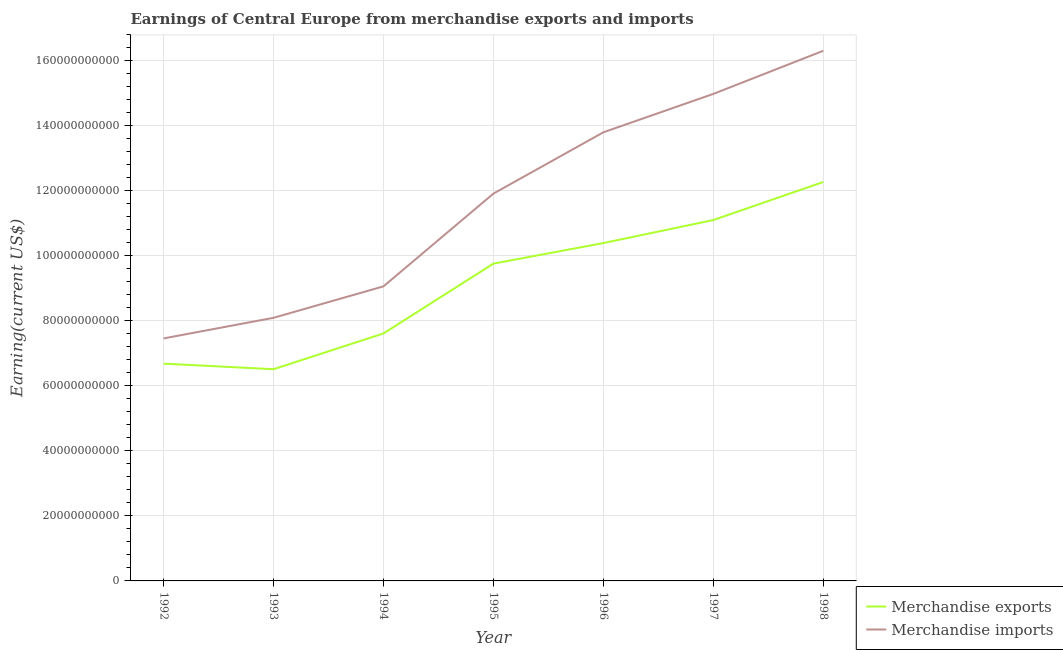How many different coloured lines are there?
Your answer should be very brief. 2. Does the line corresponding to earnings from merchandise exports intersect with the line corresponding to earnings from merchandise imports?
Make the answer very short. No. Is the number of lines equal to the number of legend labels?
Provide a succinct answer. Yes. What is the earnings from merchandise imports in 1992?
Your answer should be very brief. 7.46e+1. Across all years, what is the maximum earnings from merchandise exports?
Give a very brief answer. 1.23e+11. Across all years, what is the minimum earnings from merchandise exports?
Keep it short and to the point. 6.51e+1. In which year was the earnings from merchandise imports maximum?
Offer a terse response. 1998. What is the total earnings from merchandise imports in the graph?
Offer a very short reply. 8.16e+11. What is the difference between the earnings from merchandise imports in 1992 and that in 1997?
Ensure brevity in your answer.  -7.52e+1. What is the difference between the earnings from merchandise exports in 1996 and the earnings from merchandise imports in 1995?
Keep it short and to the point. -1.52e+1. What is the average earnings from merchandise exports per year?
Keep it short and to the point. 9.19e+1. In the year 1995, what is the difference between the earnings from merchandise imports and earnings from merchandise exports?
Your answer should be very brief. 2.15e+1. What is the ratio of the earnings from merchandise imports in 1992 to that in 1998?
Give a very brief answer. 0.46. Is the earnings from merchandise exports in 1994 less than that in 1996?
Offer a terse response. Yes. What is the difference between the highest and the second highest earnings from merchandise exports?
Your answer should be compact. 1.17e+1. What is the difference between the highest and the lowest earnings from merchandise imports?
Ensure brevity in your answer.  8.85e+1. Is the earnings from merchandise imports strictly greater than the earnings from merchandise exports over the years?
Offer a very short reply. Yes. Is the earnings from merchandise exports strictly less than the earnings from merchandise imports over the years?
Provide a short and direct response. Yes. How many years are there in the graph?
Keep it short and to the point. 7. Does the graph contain grids?
Keep it short and to the point. Yes. How many legend labels are there?
Offer a terse response. 2. What is the title of the graph?
Keep it short and to the point. Earnings of Central Europe from merchandise exports and imports. Does "Nonresident" appear as one of the legend labels in the graph?
Offer a terse response. No. What is the label or title of the Y-axis?
Make the answer very short. Earning(current US$). What is the Earning(current US$) in Merchandise exports in 1992?
Offer a very short reply. 6.69e+1. What is the Earning(current US$) in Merchandise imports in 1992?
Provide a succinct answer. 7.46e+1. What is the Earning(current US$) of Merchandise exports in 1993?
Make the answer very short. 6.51e+1. What is the Earning(current US$) of Merchandise imports in 1993?
Your answer should be compact. 8.10e+1. What is the Earning(current US$) in Merchandise exports in 1994?
Provide a short and direct response. 7.61e+1. What is the Earning(current US$) in Merchandise imports in 1994?
Offer a terse response. 9.06e+1. What is the Earning(current US$) in Merchandise exports in 1995?
Give a very brief answer. 9.76e+1. What is the Earning(current US$) in Merchandise imports in 1995?
Ensure brevity in your answer.  1.19e+11. What is the Earning(current US$) of Merchandise exports in 1996?
Offer a very short reply. 1.04e+11. What is the Earning(current US$) of Merchandise imports in 1996?
Your response must be concise. 1.38e+11. What is the Earning(current US$) of Merchandise exports in 1997?
Your answer should be compact. 1.11e+11. What is the Earning(current US$) in Merchandise imports in 1997?
Keep it short and to the point. 1.50e+11. What is the Earning(current US$) in Merchandise exports in 1998?
Give a very brief answer. 1.23e+11. What is the Earning(current US$) in Merchandise imports in 1998?
Ensure brevity in your answer.  1.63e+11. Across all years, what is the maximum Earning(current US$) in Merchandise exports?
Provide a succinct answer. 1.23e+11. Across all years, what is the maximum Earning(current US$) of Merchandise imports?
Your response must be concise. 1.63e+11. Across all years, what is the minimum Earning(current US$) of Merchandise exports?
Keep it short and to the point. 6.51e+1. Across all years, what is the minimum Earning(current US$) of Merchandise imports?
Make the answer very short. 7.46e+1. What is the total Earning(current US$) of Merchandise exports in the graph?
Your answer should be compact. 6.43e+11. What is the total Earning(current US$) in Merchandise imports in the graph?
Give a very brief answer. 8.16e+11. What is the difference between the Earning(current US$) in Merchandise exports in 1992 and that in 1993?
Your response must be concise. 1.72e+09. What is the difference between the Earning(current US$) in Merchandise imports in 1992 and that in 1993?
Provide a succinct answer. -6.34e+09. What is the difference between the Earning(current US$) in Merchandise exports in 1992 and that in 1994?
Offer a terse response. -9.28e+09. What is the difference between the Earning(current US$) of Merchandise imports in 1992 and that in 1994?
Offer a terse response. -1.60e+1. What is the difference between the Earning(current US$) in Merchandise exports in 1992 and that in 1995?
Ensure brevity in your answer.  -3.08e+1. What is the difference between the Earning(current US$) of Merchandise imports in 1992 and that in 1995?
Your answer should be compact. -4.46e+1. What is the difference between the Earning(current US$) of Merchandise exports in 1992 and that in 1996?
Ensure brevity in your answer.  -3.71e+1. What is the difference between the Earning(current US$) in Merchandise imports in 1992 and that in 1996?
Provide a succinct answer. -6.34e+1. What is the difference between the Earning(current US$) in Merchandise exports in 1992 and that in 1997?
Give a very brief answer. -4.42e+1. What is the difference between the Earning(current US$) in Merchandise imports in 1992 and that in 1997?
Offer a very short reply. -7.52e+1. What is the difference between the Earning(current US$) of Merchandise exports in 1992 and that in 1998?
Keep it short and to the point. -5.59e+1. What is the difference between the Earning(current US$) of Merchandise imports in 1992 and that in 1998?
Provide a succinct answer. -8.85e+1. What is the difference between the Earning(current US$) in Merchandise exports in 1993 and that in 1994?
Make the answer very short. -1.10e+1. What is the difference between the Earning(current US$) in Merchandise imports in 1993 and that in 1994?
Ensure brevity in your answer.  -9.67e+09. What is the difference between the Earning(current US$) in Merchandise exports in 1993 and that in 1995?
Keep it short and to the point. -3.25e+1. What is the difference between the Earning(current US$) of Merchandise imports in 1993 and that in 1995?
Ensure brevity in your answer.  -3.82e+1. What is the difference between the Earning(current US$) in Merchandise exports in 1993 and that in 1996?
Your response must be concise. -3.88e+1. What is the difference between the Earning(current US$) in Merchandise imports in 1993 and that in 1996?
Offer a terse response. -5.71e+1. What is the difference between the Earning(current US$) of Merchandise exports in 1993 and that in 1997?
Provide a succinct answer. -4.59e+1. What is the difference between the Earning(current US$) in Merchandise imports in 1993 and that in 1997?
Make the answer very short. -6.89e+1. What is the difference between the Earning(current US$) in Merchandise exports in 1993 and that in 1998?
Offer a terse response. -5.76e+1. What is the difference between the Earning(current US$) in Merchandise imports in 1993 and that in 1998?
Give a very brief answer. -8.22e+1. What is the difference between the Earning(current US$) of Merchandise exports in 1994 and that in 1995?
Your response must be concise. -2.15e+1. What is the difference between the Earning(current US$) in Merchandise imports in 1994 and that in 1995?
Provide a succinct answer. -2.85e+1. What is the difference between the Earning(current US$) in Merchandise exports in 1994 and that in 1996?
Offer a terse response. -2.78e+1. What is the difference between the Earning(current US$) of Merchandise imports in 1994 and that in 1996?
Your answer should be very brief. -4.74e+1. What is the difference between the Earning(current US$) in Merchandise exports in 1994 and that in 1997?
Make the answer very short. -3.49e+1. What is the difference between the Earning(current US$) in Merchandise imports in 1994 and that in 1997?
Provide a short and direct response. -5.92e+1. What is the difference between the Earning(current US$) of Merchandise exports in 1994 and that in 1998?
Offer a terse response. -4.66e+1. What is the difference between the Earning(current US$) in Merchandise imports in 1994 and that in 1998?
Ensure brevity in your answer.  -7.25e+1. What is the difference between the Earning(current US$) of Merchandise exports in 1995 and that in 1996?
Make the answer very short. -6.33e+09. What is the difference between the Earning(current US$) of Merchandise imports in 1995 and that in 1996?
Offer a very short reply. -1.89e+1. What is the difference between the Earning(current US$) of Merchandise exports in 1995 and that in 1997?
Provide a short and direct response. -1.34e+1. What is the difference between the Earning(current US$) of Merchandise imports in 1995 and that in 1997?
Ensure brevity in your answer.  -3.07e+1. What is the difference between the Earning(current US$) in Merchandise exports in 1995 and that in 1998?
Offer a very short reply. -2.51e+1. What is the difference between the Earning(current US$) of Merchandise imports in 1995 and that in 1998?
Provide a short and direct response. -4.39e+1. What is the difference between the Earning(current US$) of Merchandise exports in 1996 and that in 1997?
Your answer should be compact. -7.09e+09. What is the difference between the Earning(current US$) of Merchandise imports in 1996 and that in 1997?
Your response must be concise. -1.18e+1. What is the difference between the Earning(current US$) of Merchandise exports in 1996 and that in 1998?
Offer a terse response. -1.88e+1. What is the difference between the Earning(current US$) in Merchandise imports in 1996 and that in 1998?
Your answer should be very brief. -2.51e+1. What is the difference between the Earning(current US$) of Merchandise exports in 1997 and that in 1998?
Provide a short and direct response. -1.17e+1. What is the difference between the Earning(current US$) in Merchandise imports in 1997 and that in 1998?
Provide a short and direct response. -1.33e+1. What is the difference between the Earning(current US$) in Merchandise exports in 1992 and the Earning(current US$) in Merchandise imports in 1993?
Give a very brief answer. -1.41e+1. What is the difference between the Earning(current US$) of Merchandise exports in 1992 and the Earning(current US$) of Merchandise imports in 1994?
Your answer should be compact. -2.38e+1. What is the difference between the Earning(current US$) in Merchandise exports in 1992 and the Earning(current US$) in Merchandise imports in 1995?
Your answer should be compact. -5.23e+1. What is the difference between the Earning(current US$) in Merchandise exports in 1992 and the Earning(current US$) in Merchandise imports in 1996?
Give a very brief answer. -7.12e+1. What is the difference between the Earning(current US$) of Merchandise exports in 1992 and the Earning(current US$) of Merchandise imports in 1997?
Keep it short and to the point. -8.30e+1. What is the difference between the Earning(current US$) in Merchandise exports in 1992 and the Earning(current US$) in Merchandise imports in 1998?
Ensure brevity in your answer.  -9.63e+1. What is the difference between the Earning(current US$) of Merchandise exports in 1993 and the Earning(current US$) of Merchandise imports in 1994?
Keep it short and to the point. -2.55e+1. What is the difference between the Earning(current US$) in Merchandise exports in 1993 and the Earning(current US$) in Merchandise imports in 1995?
Your answer should be very brief. -5.40e+1. What is the difference between the Earning(current US$) of Merchandise exports in 1993 and the Earning(current US$) of Merchandise imports in 1996?
Give a very brief answer. -7.29e+1. What is the difference between the Earning(current US$) in Merchandise exports in 1993 and the Earning(current US$) in Merchandise imports in 1997?
Your response must be concise. -8.47e+1. What is the difference between the Earning(current US$) of Merchandise exports in 1993 and the Earning(current US$) of Merchandise imports in 1998?
Your response must be concise. -9.80e+1. What is the difference between the Earning(current US$) of Merchandise exports in 1994 and the Earning(current US$) of Merchandise imports in 1995?
Ensure brevity in your answer.  -4.30e+1. What is the difference between the Earning(current US$) in Merchandise exports in 1994 and the Earning(current US$) in Merchandise imports in 1996?
Ensure brevity in your answer.  -6.19e+1. What is the difference between the Earning(current US$) in Merchandise exports in 1994 and the Earning(current US$) in Merchandise imports in 1997?
Provide a succinct answer. -7.37e+1. What is the difference between the Earning(current US$) of Merchandise exports in 1994 and the Earning(current US$) of Merchandise imports in 1998?
Your answer should be compact. -8.70e+1. What is the difference between the Earning(current US$) in Merchandise exports in 1995 and the Earning(current US$) in Merchandise imports in 1996?
Your answer should be very brief. -4.04e+1. What is the difference between the Earning(current US$) of Merchandise exports in 1995 and the Earning(current US$) of Merchandise imports in 1997?
Your answer should be very brief. -5.22e+1. What is the difference between the Earning(current US$) in Merchandise exports in 1995 and the Earning(current US$) in Merchandise imports in 1998?
Keep it short and to the point. -6.55e+1. What is the difference between the Earning(current US$) in Merchandise exports in 1996 and the Earning(current US$) in Merchandise imports in 1997?
Offer a terse response. -4.59e+1. What is the difference between the Earning(current US$) in Merchandise exports in 1996 and the Earning(current US$) in Merchandise imports in 1998?
Provide a succinct answer. -5.92e+1. What is the difference between the Earning(current US$) of Merchandise exports in 1997 and the Earning(current US$) of Merchandise imports in 1998?
Offer a terse response. -5.21e+1. What is the average Earning(current US$) of Merchandise exports per year?
Keep it short and to the point. 9.19e+1. What is the average Earning(current US$) in Merchandise imports per year?
Ensure brevity in your answer.  1.17e+11. In the year 1992, what is the difference between the Earning(current US$) in Merchandise exports and Earning(current US$) in Merchandise imports?
Offer a terse response. -7.76e+09. In the year 1993, what is the difference between the Earning(current US$) of Merchandise exports and Earning(current US$) of Merchandise imports?
Provide a short and direct response. -1.58e+1. In the year 1994, what is the difference between the Earning(current US$) of Merchandise exports and Earning(current US$) of Merchandise imports?
Keep it short and to the point. -1.45e+1. In the year 1995, what is the difference between the Earning(current US$) of Merchandise exports and Earning(current US$) of Merchandise imports?
Your answer should be very brief. -2.15e+1. In the year 1996, what is the difference between the Earning(current US$) in Merchandise exports and Earning(current US$) in Merchandise imports?
Ensure brevity in your answer.  -3.41e+1. In the year 1997, what is the difference between the Earning(current US$) of Merchandise exports and Earning(current US$) of Merchandise imports?
Keep it short and to the point. -3.88e+1. In the year 1998, what is the difference between the Earning(current US$) of Merchandise exports and Earning(current US$) of Merchandise imports?
Give a very brief answer. -4.04e+1. What is the ratio of the Earning(current US$) of Merchandise exports in 1992 to that in 1993?
Make the answer very short. 1.03. What is the ratio of the Earning(current US$) in Merchandise imports in 1992 to that in 1993?
Your answer should be compact. 0.92. What is the ratio of the Earning(current US$) of Merchandise exports in 1992 to that in 1994?
Ensure brevity in your answer.  0.88. What is the ratio of the Earning(current US$) in Merchandise imports in 1992 to that in 1994?
Provide a succinct answer. 0.82. What is the ratio of the Earning(current US$) of Merchandise exports in 1992 to that in 1995?
Offer a terse response. 0.68. What is the ratio of the Earning(current US$) in Merchandise imports in 1992 to that in 1995?
Your answer should be very brief. 0.63. What is the ratio of the Earning(current US$) in Merchandise exports in 1992 to that in 1996?
Your response must be concise. 0.64. What is the ratio of the Earning(current US$) of Merchandise imports in 1992 to that in 1996?
Keep it short and to the point. 0.54. What is the ratio of the Earning(current US$) of Merchandise exports in 1992 to that in 1997?
Ensure brevity in your answer.  0.6. What is the ratio of the Earning(current US$) of Merchandise imports in 1992 to that in 1997?
Give a very brief answer. 0.5. What is the ratio of the Earning(current US$) of Merchandise exports in 1992 to that in 1998?
Provide a succinct answer. 0.54. What is the ratio of the Earning(current US$) in Merchandise imports in 1992 to that in 1998?
Ensure brevity in your answer.  0.46. What is the ratio of the Earning(current US$) in Merchandise exports in 1993 to that in 1994?
Ensure brevity in your answer.  0.86. What is the ratio of the Earning(current US$) of Merchandise imports in 1993 to that in 1994?
Provide a succinct answer. 0.89. What is the ratio of the Earning(current US$) of Merchandise exports in 1993 to that in 1995?
Provide a succinct answer. 0.67. What is the ratio of the Earning(current US$) in Merchandise imports in 1993 to that in 1995?
Your response must be concise. 0.68. What is the ratio of the Earning(current US$) of Merchandise exports in 1993 to that in 1996?
Offer a very short reply. 0.63. What is the ratio of the Earning(current US$) of Merchandise imports in 1993 to that in 1996?
Offer a very short reply. 0.59. What is the ratio of the Earning(current US$) of Merchandise exports in 1993 to that in 1997?
Your answer should be very brief. 0.59. What is the ratio of the Earning(current US$) of Merchandise imports in 1993 to that in 1997?
Give a very brief answer. 0.54. What is the ratio of the Earning(current US$) in Merchandise exports in 1993 to that in 1998?
Offer a terse response. 0.53. What is the ratio of the Earning(current US$) of Merchandise imports in 1993 to that in 1998?
Offer a very short reply. 0.5. What is the ratio of the Earning(current US$) in Merchandise exports in 1994 to that in 1995?
Your answer should be very brief. 0.78. What is the ratio of the Earning(current US$) in Merchandise imports in 1994 to that in 1995?
Make the answer very short. 0.76. What is the ratio of the Earning(current US$) in Merchandise exports in 1994 to that in 1996?
Make the answer very short. 0.73. What is the ratio of the Earning(current US$) of Merchandise imports in 1994 to that in 1996?
Your response must be concise. 0.66. What is the ratio of the Earning(current US$) in Merchandise exports in 1994 to that in 1997?
Ensure brevity in your answer.  0.69. What is the ratio of the Earning(current US$) in Merchandise imports in 1994 to that in 1997?
Make the answer very short. 0.6. What is the ratio of the Earning(current US$) in Merchandise exports in 1994 to that in 1998?
Offer a very short reply. 0.62. What is the ratio of the Earning(current US$) of Merchandise imports in 1994 to that in 1998?
Provide a succinct answer. 0.56. What is the ratio of the Earning(current US$) in Merchandise exports in 1995 to that in 1996?
Make the answer very short. 0.94. What is the ratio of the Earning(current US$) in Merchandise imports in 1995 to that in 1996?
Offer a very short reply. 0.86. What is the ratio of the Earning(current US$) of Merchandise exports in 1995 to that in 1997?
Keep it short and to the point. 0.88. What is the ratio of the Earning(current US$) of Merchandise imports in 1995 to that in 1997?
Ensure brevity in your answer.  0.8. What is the ratio of the Earning(current US$) in Merchandise exports in 1995 to that in 1998?
Your response must be concise. 0.8. What is the ratio of the Earning(current US$) in Merchandise imports in 1995 to that in 1998?
Make the answer very short. 0.73. What is the ratio of the Earning(current US$) in Merchandise exports in 1996 to that in 1997?
Provide a short and direct response. 0.94. What is the ratio of the Earning(current US$) in Merchandise imports in 1996 to that in 1997?
Provide a succinct answer. 0.92. What is the ratio of the Earning(current US$) in Merchandise exports in 1996 to that in 1998?
Ensure brevity in your answer.  0.85. What is the ratio of the Earning(current US$) in Merchandise imports in 1996 to that in 1998?
Provide a succinct answer. 0.85. What is the ratio of the Earning(current US$) in Merchandise exports in 1997 to that in 1998?
Your response must be concise. 0.9. What is the ratio of the Earning(current US$) in Merchandise imports in 1997 to that in 1998?
Offer a terse response. 0.92. What is the difference between the highest and the second highest Earning(current US$) of Merchandise exports?
Make the answer very short. 1.17e+1. What is the difference between the highest and the second highest Earning(current US$) of Merchandise imports?
Your answer should be compact. 1.33e+1. What is the difference between the highest and the lowest Earning(current US$) in Merchandise exports?
Offer a very short reply. 5.76e+1. What is the difference between the highest and the lowest Earning(current US$) in Merchandise imports?
Your answer should be compact. 8.85e+1. 